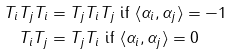<formula> <loc_0><loc_0><loc_500><loc_500>T _ { i } T _ { j } T _ { i } & = T _ { j } T _ { i } T _ { j } \text { if } \langle \alpha _ { i } , \alpha _ { j } \rangle = - 1 \\ T _ { i } T _ { j } & = T _ { j } T _ { i } \text { if } \langle \alpha _ { i } , \alpha _ { j } \rangle = 0</formula> 